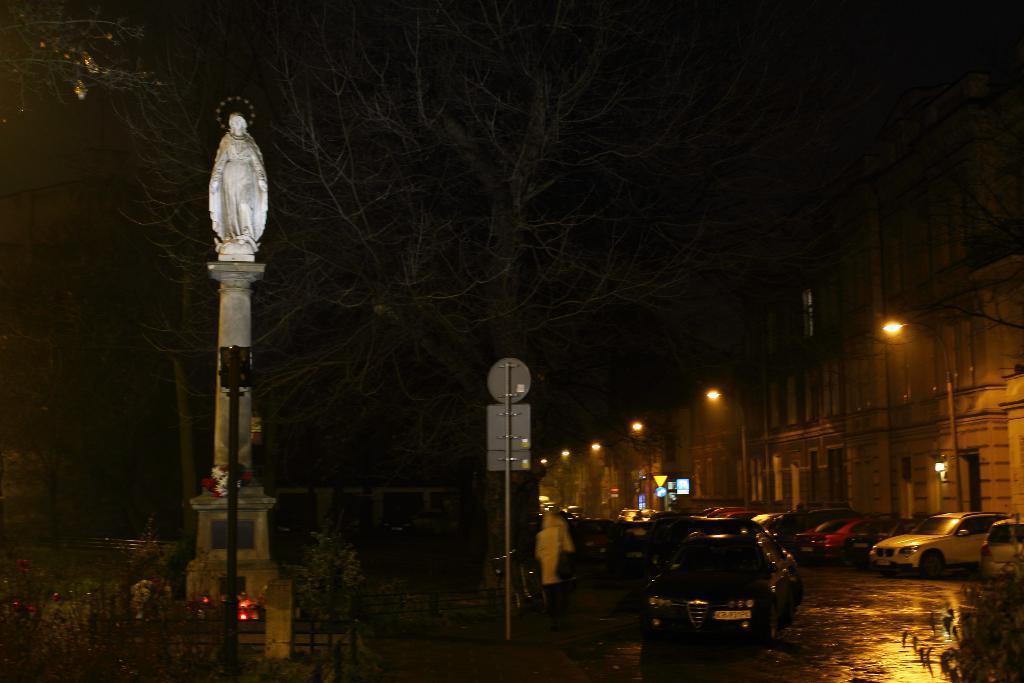Can you describe this image briefly? In this image there is a statue in the middle. On the right side there is a road on which there are so many cars. There are street lights on the footpath. Beside the footpath there are buildings. The image is taken in the nighttime. In the background there are trees. In the middle there is a signal board. 